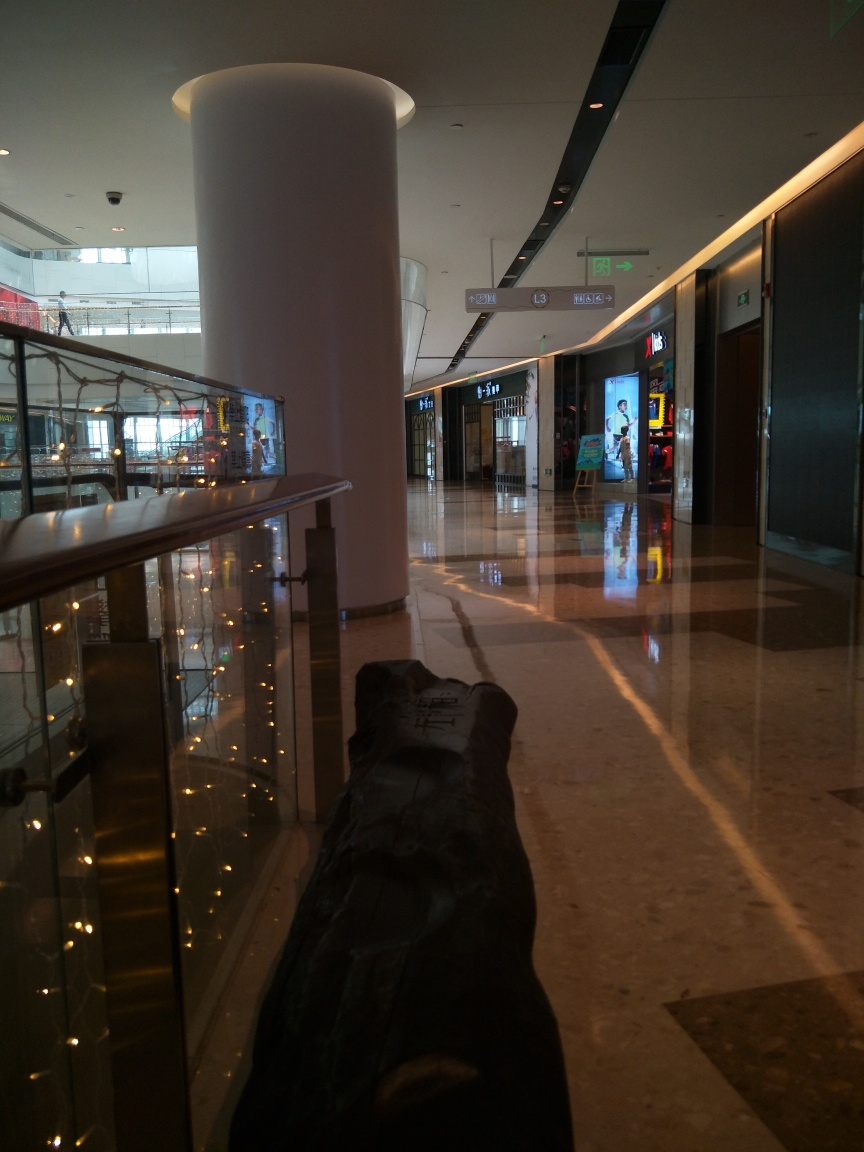Is the image too dark? The image is moderately lit, with some areas appearing dark due to the contrast between the interior lighting and the daylight streaming in from outside. Shadows are visible, which may give the impression of darkness in certain parts, but overall details are still discernible. 